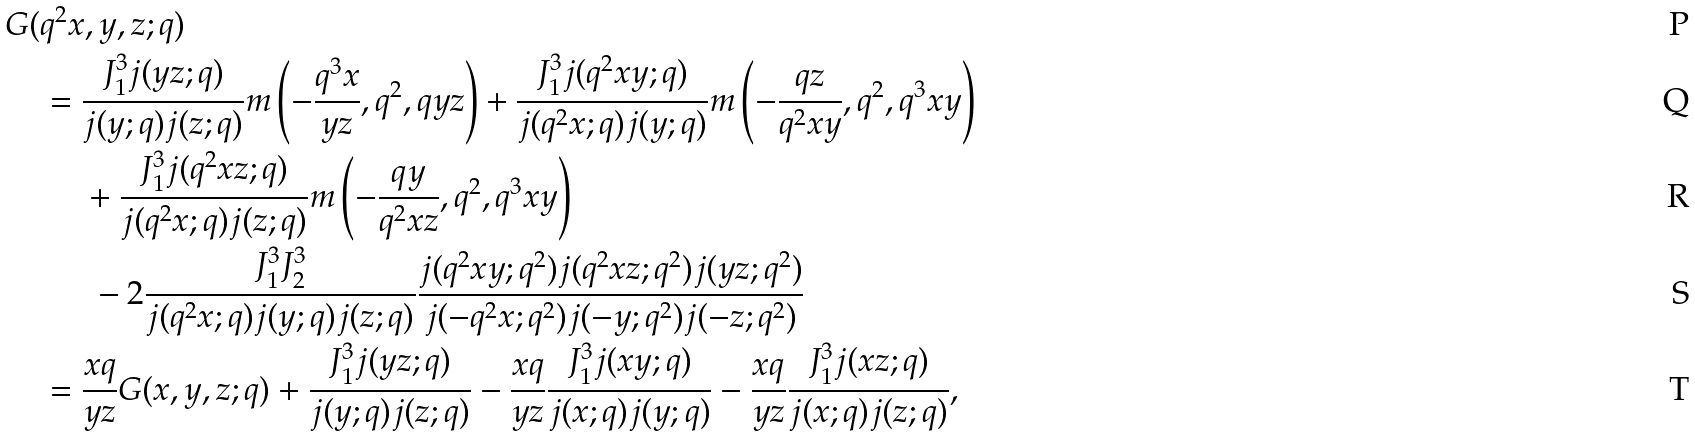<formula> <loc_0><loc_0><loc_500><loc_500>G ( & q ^ { 2 } x , y , z ; q ) \\ & = \frac { J _ { 1 } ^ { 3 } j ( y z ; q ) } { j ( y ; q ) j ( z ; q ) } m \left ( - \frac { q ^ { 3 } x } { y z } , q ^ { 2 } , q y z \right ) + \frac { J _ { 1 } ^ { 3 } j ( q ^ { 2 } x y ; q ) } { j ( q ^ { 2 } x ; q ) j ( y ; q ) } m \left ( - \frac { q z } { q ^ { 2 } x y } , q ^ { 2 } , q ^ { 3 } x y \right ) \\ & \quad \ + \frac { J _ { 1 } ^ { 3 } j ( q ^ { 2 } x z ; q ) } { j ( q ^ { 2 } x ; q ) j ( z ; q ) } m \left ( - \frac { q y } { q ^ { 2 } x z } , q ^ { 2 } , q ^ { 3 } x y \right ) \\ & \quad \ \ - 2 \frac { J _ { 1 } ^ { 3 } J _ { 2 } ^ { 3 } } { j ( q ^ { 2 } x ; q ) j ( y ; q ) j ( z ; q ) } \frac { j ( q ^ { 2 } x y ; q ^ { 2 } ) j ( q ^ { 2 } x z ; q ^ { 2 } ) j ( y z ; q ^ { 2 } ) } { j ( - q ^ { 2 } x ; q ^ { 2 } ) j ( - y ; q ^ { 2 } ) j ( - z ; q ^ { 2 } ) } \\ & = \frac { x q } { y z } G ( x , y , z ; q ) + \frac { J _ { 1 } ^ { 3 } j ( y z ; q ) } { j ( y ; q ) j ( z ; q ) } - \frac { x q } { y z } \frac { J _ { 1 } ^ { 3 } j ( x y ; q ) } { j ( x ; q ) j ( y ; q ) } - \frac { x q } { y z } \frac { J _ { 1 } ^ { 3 } j ( x z ; q ) } { j ( x ; q ) j ( z ; q ) } ,</formula> 